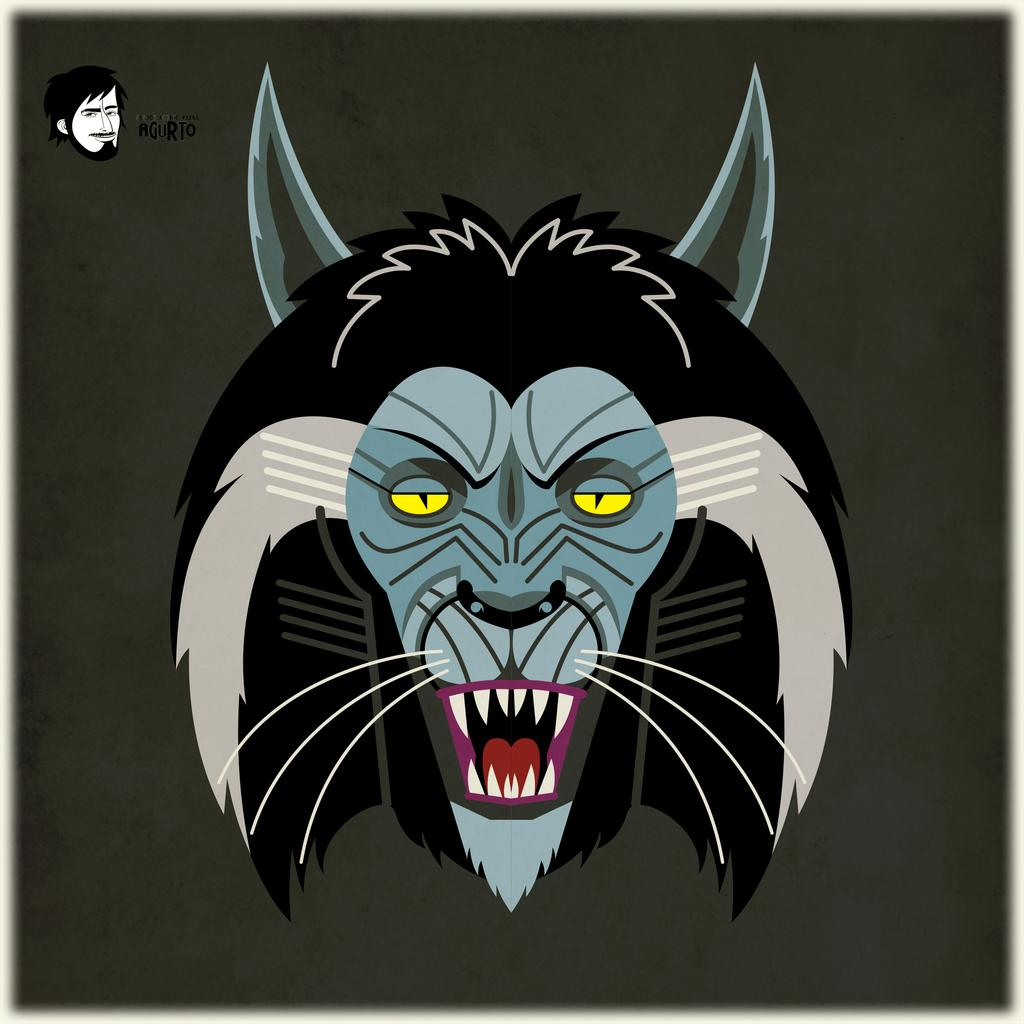What is the main subject in the foreground of the image? There is a cartoon face of a lion in the foreground of the image. What color is the background of the image? The background of the image is black. What decision does the lion make in the image? There is no indication of the lion making a decision in the image, as it is a static cartoon face. What type of ink is used to draw the lion in the image? The type of ink used to draw the lion is not visible or mentioned in the image, so it cannot be determined. 